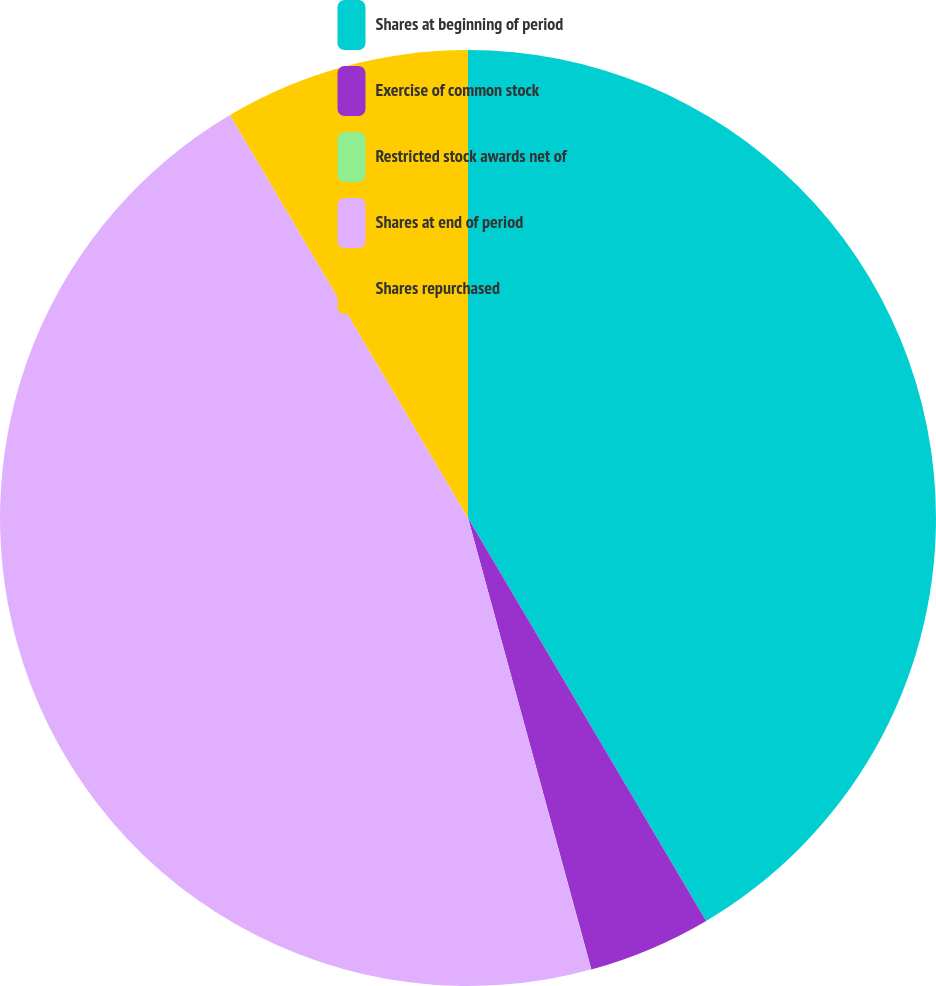Convert chart to OTSL. <chart><loc_0><loc_0><loc_500><loc_500><pie_chart><fcel>Shares at beginning of period<fcel>Exercise of common stock<fcel>Restricted stock awards net of<fcel>Shares at end of period<fcel>Shares repurchased<nl><fcel>41.5%<fcel>4.25%<fcel>0.01%<fcel>45.74%<fcel>8.49%<nl></chart> 